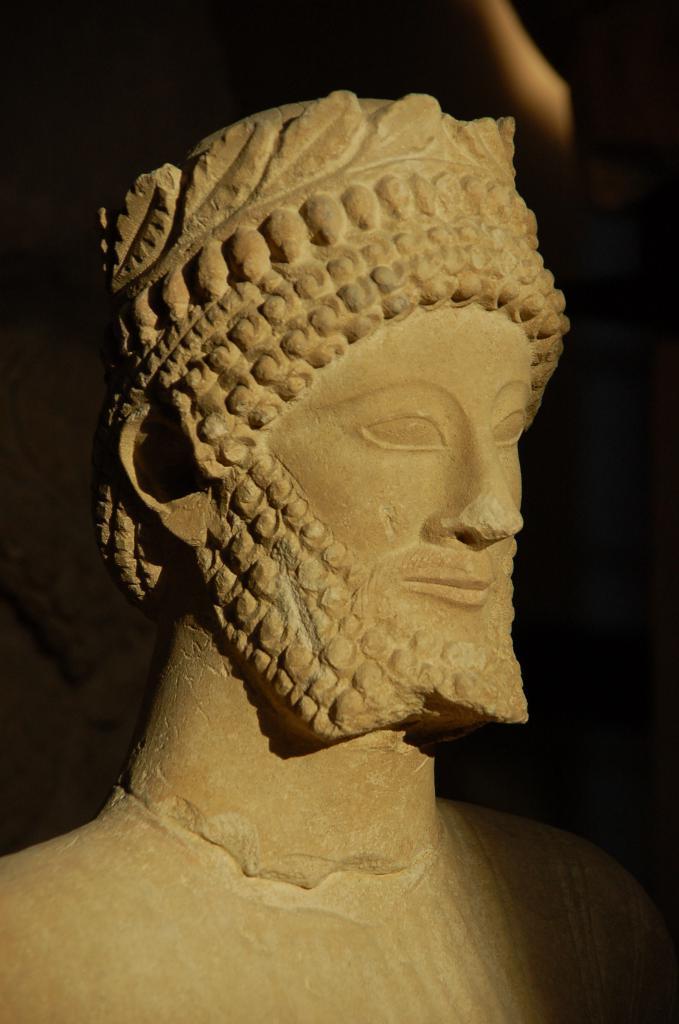Please provide a concise description of this image. In this image I can see the statue of the person. And there is a black background. 